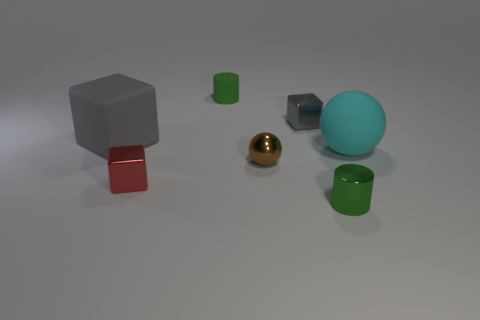What is the shape of the gray metallic object that is the same size as the brown shiny ball? The shape of the gray metallic object that is the same in size as the brown shiny ball is a cube. It appears to have equal sides and sharp edges, typical of cubic geometry. 